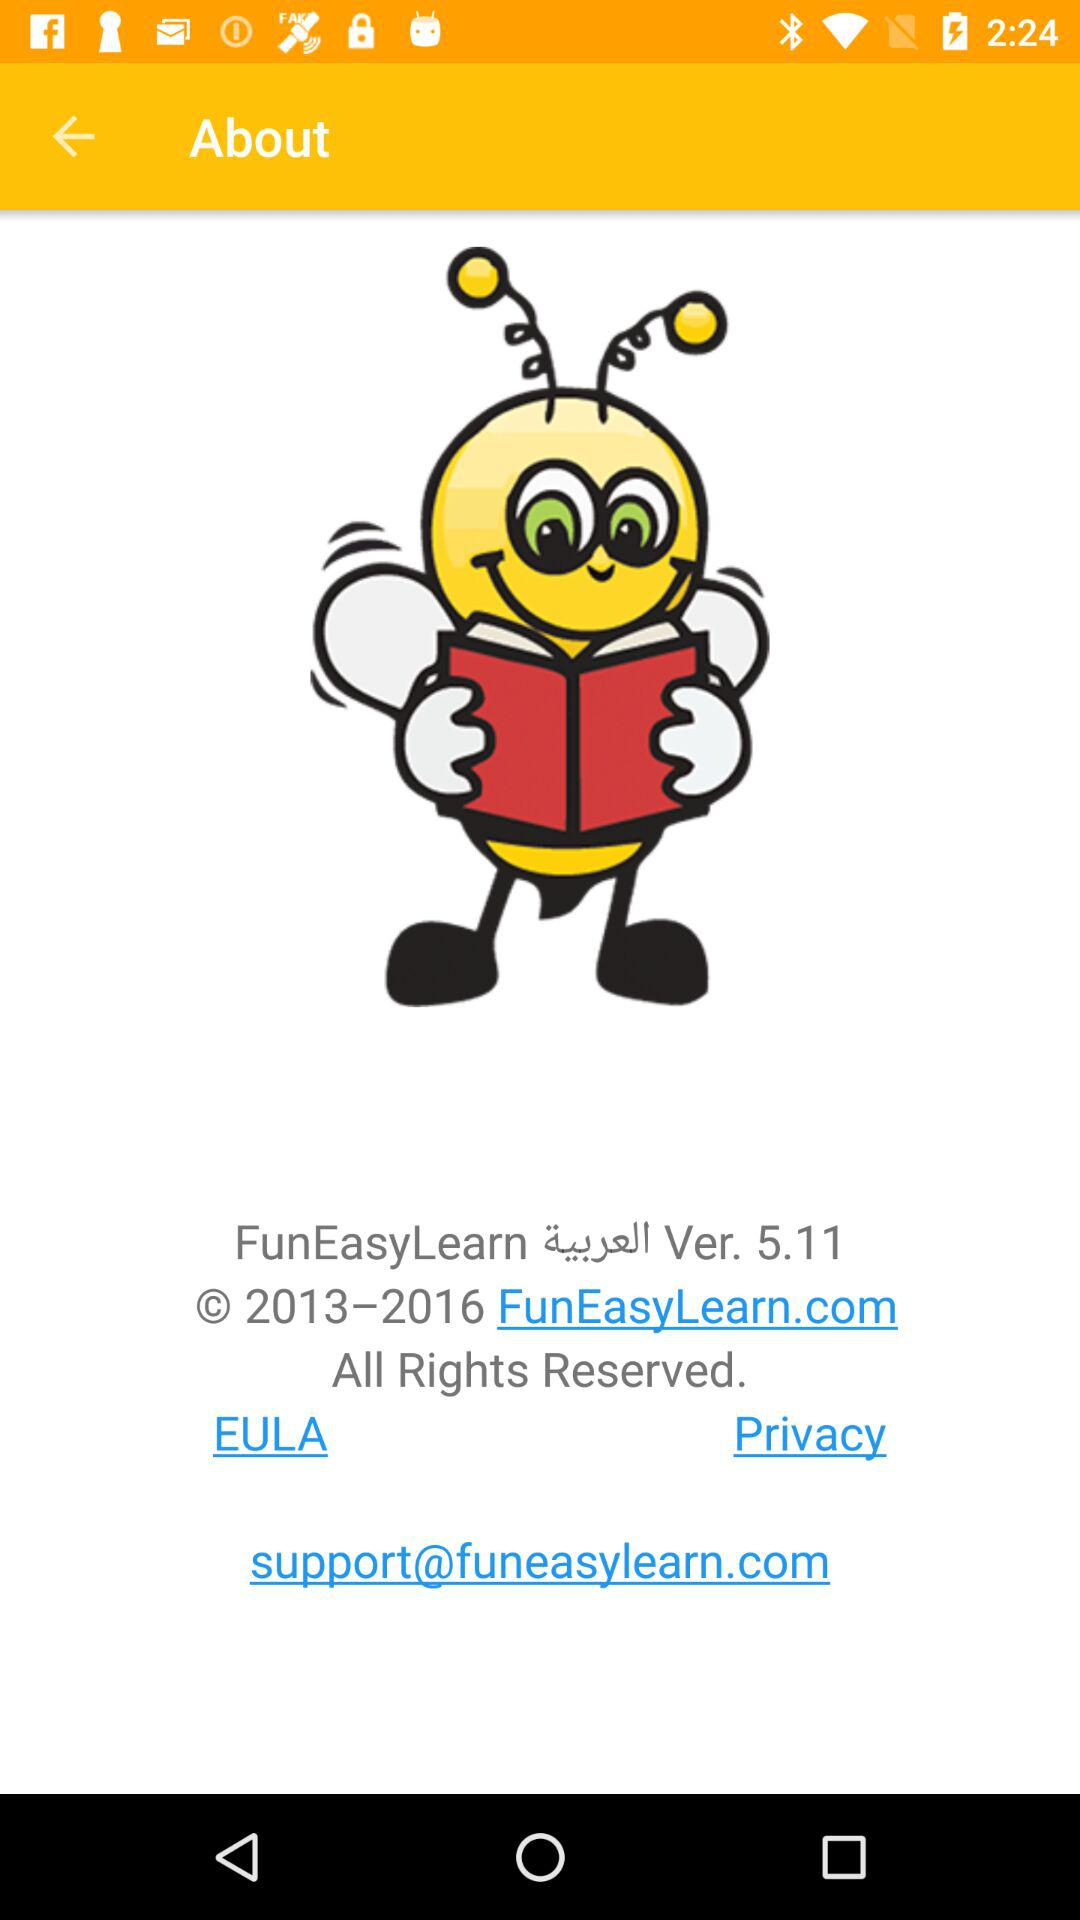What is the copyright year? The copyright year is from 2013 to 2016. 